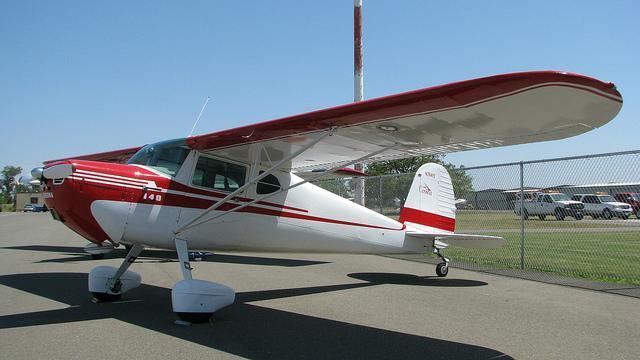How many wheels does the airplane have?
Give a very brief answer. 3. 